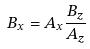Convert formula to latex. <formula><loc_0><loc_0><loc_500><loc_500>B _ { x } = A _ { x } \frac { B _ { z } } { A _ { z } }</formula> 